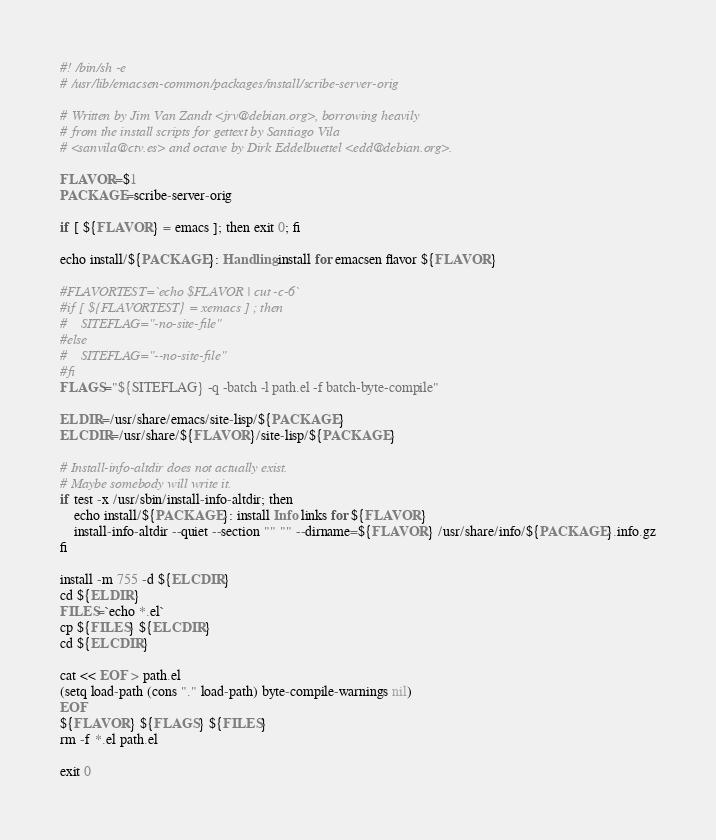<code> <loc_0><loc_0><loc_500><loc_500><_Elixir_>#! /bin/sh -e
# /usr/lib/emacsen-common/packages/install/scribe-server-orig

# Written by Jim Van Zandt <jrv@debian.org>, borrowing heavily
# from the install scripts for gettext by Santiago Vila
# <sanvila@ctv.es> and octave by Dirk Eddelbuettel <edd@debian.org>.

FLAVOR=$1
PACKAGE=scribe-server-orig

if [ ${FLAVOR} = emacs ]; then exit 0; fi

echo install/${PACKAGE}: Handling install for emacsen flavor ${FLAVOR}

#FLAVORTEST=`echo $FLAVOR | cut -c-6`
#if [ ${FLAVORTEST} = xemacs ] ; then
#    SITEFLAG="-no-site-file"
#else
#    SITEFLAG="--no-site-file"
#fi
FLAGS="${SITEFLAG} -q -batch -l path.el -f batch-byte-compile"

ELDIR=/usr/share/emacs/site-lisp/${PACKAGE}
ELCDIR=/usr/share/${FLAVOR}/site-lisp/${PACKAGE}

# Install-info-altdir does not actually exist.
# Maybe somebody will write it.
if test -x /usr/sbin/install-info-altdir; then
    echo install/${PACKAGE}: install Info links for ${FLAVOR}
    install-info-altdir --quiet --section "" "" --dirname=${FLAVOR} /usr/share/info/${PACKAGE}.info.gz
fi

install -m 755 -d ${ELCDIR}
cd ${ELDIR}
FILES=`echo *.el`
cp ${FILES} ${ELCDIR}
cd ${ELCDIR}

cat << EOF > path.el
(setq load-path (cons "." load-path) byte-compile-warnings nil)
EOF
${FLAVOR} ${FLAGS} ${FILES}
rm -f *.el path.el

exit 0
</code> 